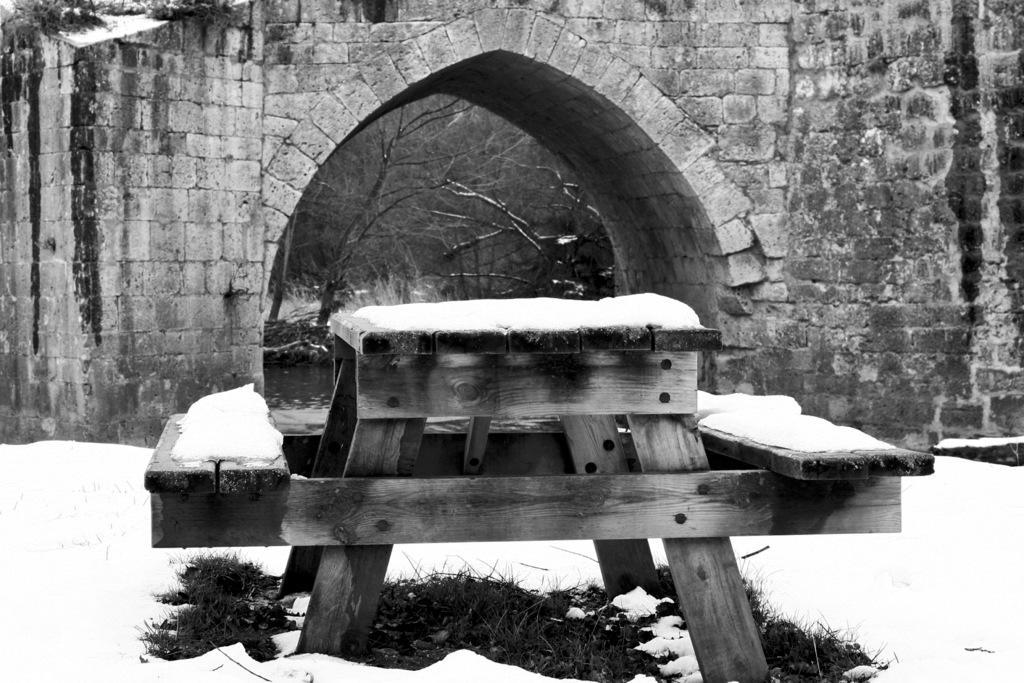Could you give a brief overview of what you see in this image? This is a black and white image where we can see bench and snow, behind that there is a view of trees and water from the arch. 